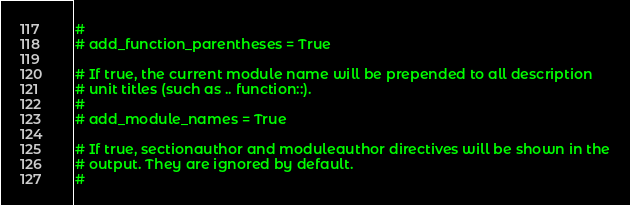Convert code to text. <code><loc_0><loc_0><loc_500><loc_500><_Python_>#
# add_function_parentheses = True

# If true, the current module name will be prepended to all description
# unit titles (such as .. function::).
#
# add_module_names = True

# If true, sectionauthor and moduleauthor directives will be shown in the
# output. They are ignored by default.
#</code> 